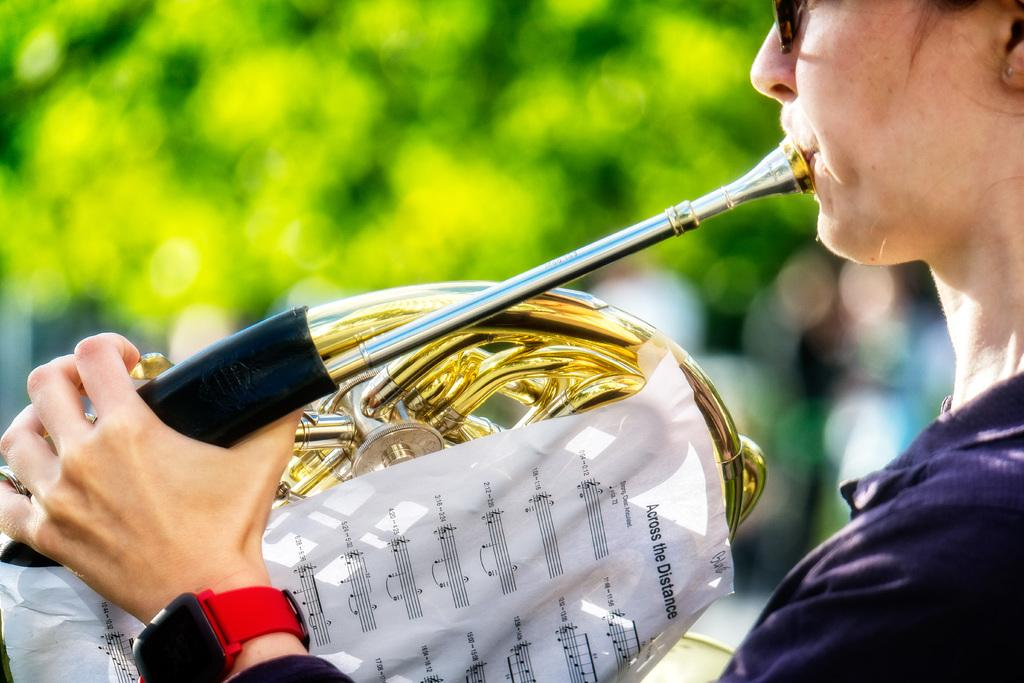<image>
Render a clear and concise summary of the photo. A woman plays an instrument while holding sheet music titled Across the Distance. 